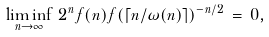Convert formula to latex. <formula><loc_0><loc_0><loc_500><loc_500>\liminf _ { n \to \infty } \, 2 ^ { n } f ( n ) f ( \lceil n / \omega ( n ) \rceil ) ^ { - n / 2 } \, = \, 0 ,</formula> 